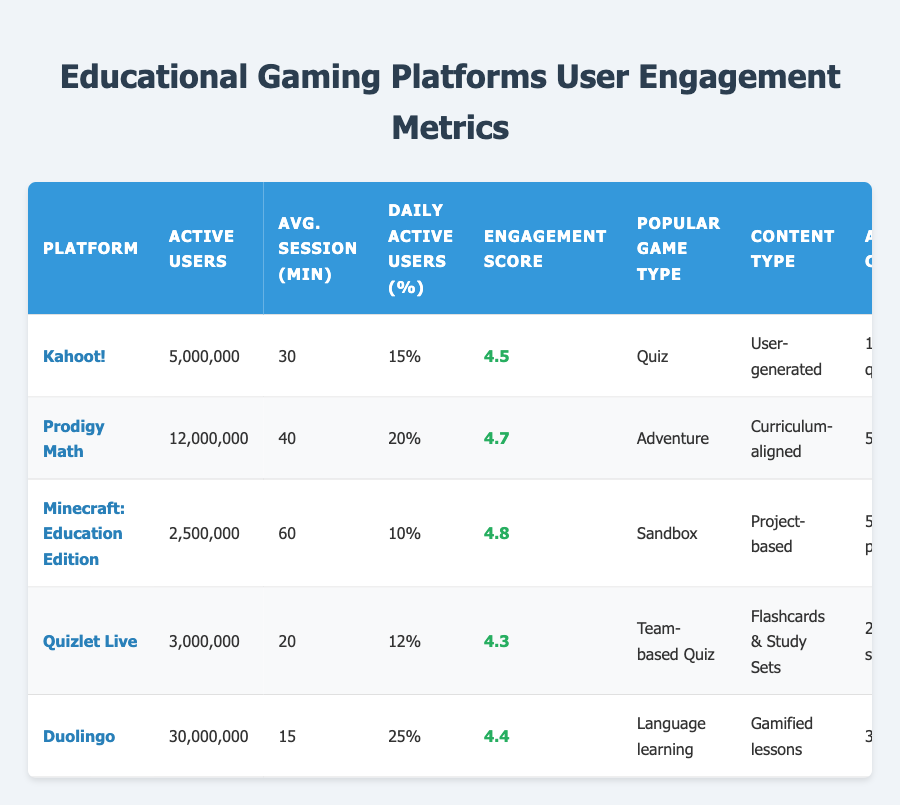What is the average session duration for Prodigy Math? The table shows that the average session duration for Prodigy Math is 40 minutes, as indicated in the corresponding cell of that row.
Answer: 40 minutes Which platform has the highest engagement score? By looking at the "Engagement Score" column, Minecraft: Education Edition has the highest engagement score of 4.8.
Answer: Minecraft: Education Edition What percentage of active users is daily active on Kahoot! compared to Duolingo? Kahoot! has 15% of its active users daily active, while Duolingo has 25%. Therefore, Duolingo has 10% more daily active users compared to Kahoot!.
Answer: 10% Is the most popular game type for Quizlet Live a "Team-based Quiz"? The table indicates that Quizlet Live’s most popular game type is indeed "Team-based Quiz".
Answer: Yes What is the total number of active users across all platforms listed? To find the total, sum the active users: 5,000,000 (Kahoot!) + 12,000,000 (Prodigy Math) + 2,500,000 (Minecraft) + 3,000,000 (Quizlet Live) + 30,000,000 (Duolingo) = 52,500,000 active users.
Answer: 52,500,000 Which platform has the least active users and what is their average session duration? The platform with the least active users is Minecraft: Education Edition with 2,500,000 active users, and its average session duration is 60 minutes, as shown in the respective row.
Answer: 60 minutes How many quizzes are available on Kahoot! compared to study sets on Quizlet Live? Kahoot! has 1,000,000 quizzes available, while Quizlet Live has 2,000,000 study sets available. Quizlet Live has 1,000,000 more available than Kahoot!.
Answer: 1,000,000 more What is the engagement score difference between Prodigy Math and Quizlet Live? Prodigy Math has an engagement score of 4.7 and Quizlet Live has 4.3. The difference is 4.7 - 4.3 = 0.4.
Answer: 0.4 Based on the data, does Minecraft: Education Edition have a higher percentage of daily active users compared to Kahoot!? Minecraft: Education Edition has 10% of active users daily active, whereas Kahoot! has 15%. Therefore, Kahoot! has a higher percentage of daily active users.
Answer: No 